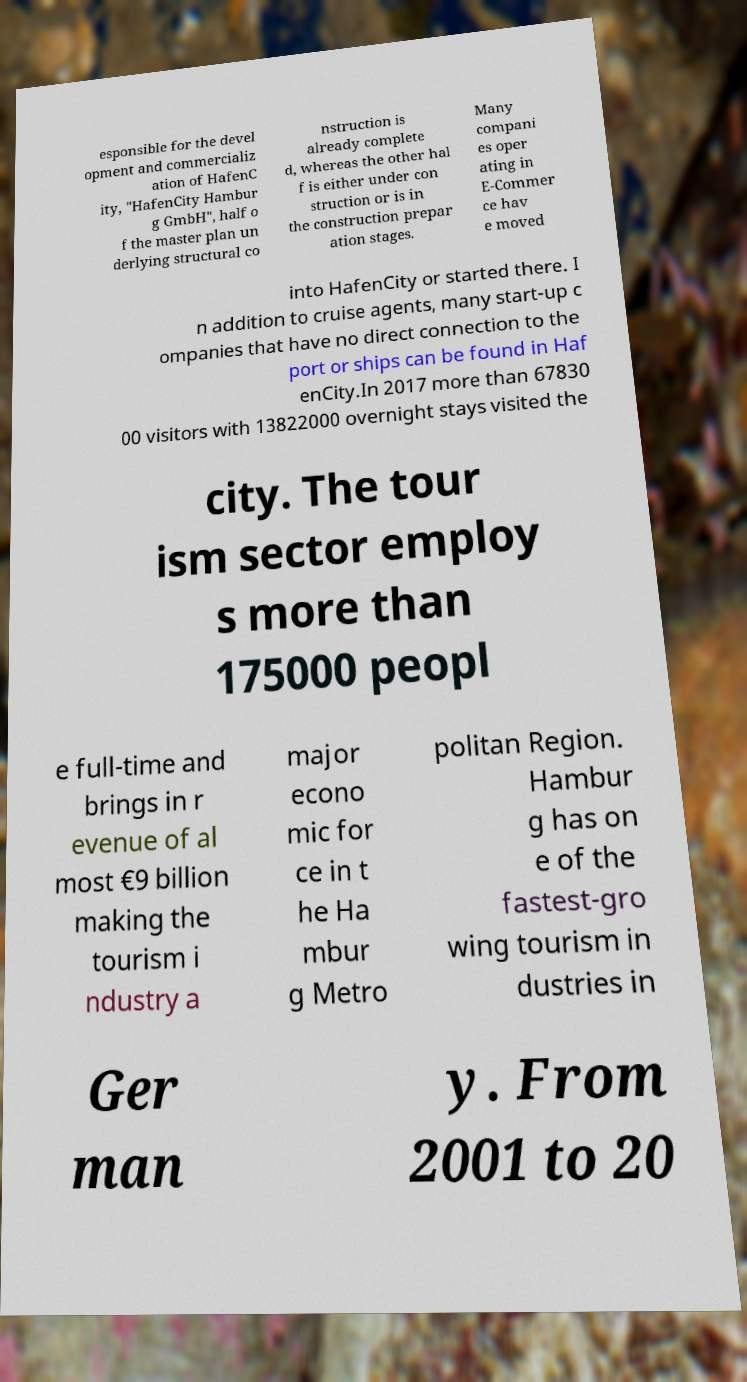What messages or text are displayed in this image? I need them in a readable, typed format. esponsible for the devel opment and commercializ ation of HafenC ity, "HafenCity Hambur g GmbH", half o f the master plan un derlying structural co nstruction is already complete d, whereas the other hal f is either under con struction or is in the construction prepar ation stages. Many compani es oper ating in E-Commer ce hav e moved into HafenCity or started there. I n addition to cruise agents, many start-up c ompanies that have no direct connection to the port or ships can be found in Haf enCity.In 2017 more than 67830 00 visitors with 13822000 overnight stays visited the city. The tour ism sector employ s more than 175000 peopl e full-time and brings in r evenue of al most €9 billion making the tourism i ndustry a major econo mic for ce in t he Ha mbur g Metro politan Region. Hambur g has on e of the fastest-gro wing tourism in dustries in Ger man y. From 2001 to 20 